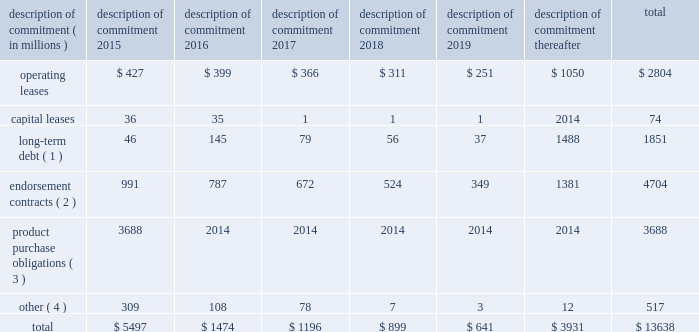Part ii on november 1 , 2011 , we entered into a committed credit facility agreement with a syndicate of banks which provides for up to $ 1 billion of borrowings with the option to increase borrowings to $ 1.5 billion with lender approval .
Following an extension agreement on september 17 , 2013 between the company and the syndicate of banks , the facility matures november 1 , 2017 , with a one-year extension option exercisable through october 31 , 2014 .
No amounts were outstanding under this facility as of may 31 , 2014 or 2013 .
We currently have long-term debt ratings of aa- and a1 from standard and poor 2019s corporation and moody 2019s investor services , respectively .
If our long- term debt rating were to decline , the facility fee and interest rate under our committed credit facility would increase .
Conversely , if our long-term debt rating were to improve , the facility fee and interest rate would decrease .
Changes in our long-term debt rating would not trigger acceleration of maturity of any then-outstanding borrowings or any future borrowings under the committed credit facility .
Under this committed revolving credit facility , we have agreed to various covenants .
These covenants include limits on our disposal of fixed assets , the amount of debt secured by liens we may incur , as well as a minimum capitalization ratio .
In the event we were to have any borrowings outstanding under this facility and failed to meet any covenant , and were unable to obtain a waiver from a majority of the banks in the syndicate , any borrowings would become immediately due and payable .
As of may 31 , 2014 , we were in full compliance with each of these covenants and believe it is unlikely we will fail to meet any of these covenants in the foreseeable future .
Liquidity is also provided by our $ 1 billion commercial paper program .
During the year ended may 31 , 2014 , we did not issue commercial paper , and as of may 31 , 2014 , there were no outstanding borrowings under this program .
We may continue to issue commercial paper or other debt securities during fiscal 2015 depending on general corporate needs .
We currently have short-term debt ratings of a1+ and p1 from standard and poor 2019s corporation and moody 2019s investor services , respectively .
As of may 31 , 2014 , we had cash , cash equivalents , and short-term investments totaling $ 5.1 billion , of which $ 2.5 billion was held by our foreign subsidiaries .
Cash equivalents and short-term investments consist primarily of deposits held at major banks , money market funds , commercial paper , corporate notes , u.s .
Treasury obligations , u.s .
Government sponsored enterprise obligations , and other investment grade fixed income securities .
Our fixed income investments are exposed to both credit and interest rate risk .
All of our investments are investment grade to minimize our credit risk .
While individual securities have varying durations , as of may 31 , 2014 the average duration of our short-term investments and cash equivalents portfolio was 126 days .
To date we have not experienced difficulty accessing the credit markets or incurred higher interest costs .
Future volatility in the capital markets , however , may increase costs associated with issuing commercial paper or other debt instruments or affect our ability to access those markets .
We believe that existing cash , cash equivalents , short-term investments , and cash generated by operations , together with access to external sources of funds as described above , will be sufficient to meet our domestic and foreign capital needs in the foreseeable future .
We utilize a variety of tax planning and financing strategies to manage our worldwide cash and deploy funds to locations where they are needed .
We routinely repatriate a portion of our foreign earnings for which u.s .
Taxes have previously been provided .
We also indefinitely reinvest a significant portion of our foreign earnings , and our current plans do not demonstrate a need to repatriate these earnings .
Should we require additional capital in the united states , we may elect to repatriate indefinitely reinvested foreign funds or raise capital in the united states through debt .
If we were to repatriate indefinitely reinvested foreign funds , we would be required to accrue and pay additional u.s .
Taxes less applicable foreign tax credits .
If we elect to raise capital in the united states through debt , we would incur additional interest expense .
Off-balance sheet arrangements in connection with various contracts and agreements , we routinely provide indemnification relating to the enforceability of intellectual property rights , coverage for legal issues that arise and other items where we are acting as the guarantor .
Currently , we have several such agreements in place .
However , based on our historical experience and the estimated probability of future loss , we have determined that the fair value of such indemnification is not material to our financial position or results of operations .
Contractual obligations our significant long-term contractual obligations as of may 31 , 2014 and significant endorsement contracts entered into through the date of this report are as follows: .
( 1 ) the cash payments due for long-term debt include estimated interest payments .
Estimates of interest payments are based on outstanding principal amounts , applicable fixed interest rates or currently effective interest rates as of may 31 , 2014 ( if variable ) , timing of scheduled payments , and the term of the debt obligations .
( 2 ) the amounts listed for endorsement contracts represent approximate amounts of base compensation and minimum guaranteed royalty fees we are obligated to pay athlete and sport team endorsers of our products .
Actual payments under some contracts may be higher than the amounts listed as these contracts provide for bonuses to be paid to the endorsers based upon athletic achievements and/or royalties on product sales in future periods .
Actual payments under some contracts may also be lower as these contracts include provisions for reduced payments if athletic performance declines in future periods .
In addition to the cash payments , we are obligated to furnish our endorsers with nike product for their use .
It is not possible to determine how much we will spend on this product on an annual basis as the contracts generally do not stipulate a specific amount of cash to be spent on the product .
The amount of product provided to the endorsers will depend on many factors , including general playing conditions , the number of sporting events in which they participate , and our own decisions regarding product and marketing initiatives .
In addition , the costs to design , develop , source , and purchase the products furnished to the endorsers are incurred over a period of time and are not necessarily tracked separately from similar costs incurred for products sold to customers .
( 3 ) we generally order product at least four to five months in advance of sale based primarily on futures orders received from customers .
The amounts listed for product purchase obligations represent agreements ( including open purchase orders ) to purchase products in the ordinary course of business that are enforceable and legally binding and that specify all significant terms .
In some cases , prices are subject to change throughout the production process .
The reported amounts exclude product purchase liabilities included in accounts payable on the consolidated balance sheet as of may 31 , 2014 .
( 4 ) other amounts primarily include service and marketing commitments made in the ordinary course of business .
The amounts represent the minimum payments required by legally binding contracts and agreements that specify all significant terms , including open purchase orders for non-product purchases .
The reported amounts exclude those liabilities included in accounts payable or accrued liabilities on the consolidated balance sheet as of may 31 , 2014 .
Nike , inc .
2014 annual report and notice of annual meeting 79 .
What percentage of the total for 2015 were due to to operating leases? 
Computations: (427 / 5497)
Answer: 0.07768. Part ii on november 1 , 2011 , we entered into a committed credit facility agreement with a syndicate of banks which provides for up to $ 1 billion of borrowings with the option to increase borrowings to $ 1.5 billion with lender approval .
Following an extension agreement on september 17 , 2013 between the company and the syndicate of banks , the facility matures november 1 , 2017 , with a one-year extension option exercisable through october 31 , 2014 .
No amounts were outstanding under this facility as of may 31 , 2014 or 2013 .
We currently have long-term debt ratings of aa- and a1 from standard and poor 2019s corporation and moody 2019s investor services , respectively .
If our long- term debt rating were to decline , the facility fee and interest rate under our committed credit facility would increase .
Conversely , if our long-term debt rating were to improve , the facility fee and interest rate would decrease .
Changes in our long-term debt rating would not trigger acceleration of maturity of any then-outstanding borrowings or any future borrowings under the committed credit facility .
Under this committed revolving credit facility , we have agreed to various covenants .
These covenants include limits on our disposal of fixed assets , the amount of debt secured by liens we may incur , as well as a minimum capitalization ratio .
In the event we were to have any borrowings outstanding under this facility and failed to meet any covenant , and were unable to obtain a waiver from a majority of the banks in the syndicate , any borrowings would become immediately due and payable .
As of may 31 , 2014 , we were in full compliance with each of these covenants and believe it is unlikely we will fail to meet any of these covenants in the foreseeable future .
Liquidity is also provided by our $ 1 billion commercial paper program .
During the year ended may 31 , 2014 , we did not issue commercial paper , and as of may 31 , 2014 , there were no outstanding borrowings under this program .
We may continue to issue commercial paper or other debt securities during fiscal 2015 depending on general corporate needs .
We currently have short-term debt ratings of a1+ and p1 from standard and poor 2019s corporation and moody 2019s investor services , respectively .
As of may 31 , 2014 , we had cash , cash equivalents , and short-term investments totaling $ 5.1 billion , of which $ 2.5 billion was held by our foreign subsidiaries .
Cash equivalents and short-term investments consist primarily of deposits held at major banks , money market funds , commercial paper , corporate notes , u.s .
Treasury obligations , u.s .
Government sponsored enterprise obligations , and other investment grade fixed income securities .
Our fixed income investments are exposed to both credit and interest rate risk .
All of our investments are investment grade to minimize our credit risk .
While individual securities have varying durations , as of may 31 , 2014 the average duration of our short-term investments and cash equivalents portfolio was 126 days .
To date we have not experienced difficulty accessing the credit markets or incurred higher interest costs .
Future volatility in the capital markets , however , may increase costs associated with issuing commercial paper or other debt instruments or affect our ability to access those markets .
We believe that existing cash , cash equivalents , short-term investments , and cash generated by operations , together with access to external sources of funds as described above , will be sufficient to meet our domestic and foreign capital needs in the foreseeable future .
We utilize a variety of tax planning and financing strategies to manage our worldwide cash and deploy funds to locations where they are needed .
We routinely repatriate a portion of our foreign earnings for which u.s .
Taxes have previously been provided .
We also indefinitely reinvest a significant portion of our foreign earnings , and our current plans do not demonstrate a need to repatriate these earnings .
Should we require additional capital in the united states , we may elect to repatriate indefinitely reinvested foreign funds or raise capital in the united states through debt .
If we were to repatriate indefinitely reinvested foreign funds , we would be required to accrue and pay additional u.s .
Taxes less applicable foreign tax credits .
If we elect to raise capital in the united states through debt , we would incur additional interest expense .
Off-balance sheet arrangements in connection with various contracts and agreements , we routinely provide indemnification relating to the enforceability of intellectual property rights , coverage for legal issues that arise and other items where we are acting as the guarantor .
Currently , we have several such agreements in place .
However , based on our historical experience and the estimated probability of future loss , we have determined that the fair value of such indemnification is not material to our financial position or results of operations .
Contractual obligations our significant long-term contractual obligations as of may 31 , 2014 and significant endorsement contracts entered into through the date of this report are as follows: .
( 1 ) the cash payments due for long-term debt include estimated interest payments .
Estimates of interest payments are based on outstanding principal amounts , applicable fixed interest rates or currently effective interest rates as of may 31 , 2014 ( if variable ) , timing of scheduled payments , and the term of the debt obligations .
( 2 ) the amounts listed for endorsement contracts represent approximate amounts of base compensation and minimum guaranteed royalty fees we are obligated to pay athlete and sport team endorsers of our products .
Actual payments under some contracts may be higher than the amounts listed as these contracts provide for bonuses to be paid to the endorsers based upon athletic achievements and/or royalties on product sales in future periods .
Actual payments under some contracts may also be lower as these contracts include provisions for reduced payments if athletic performance declines in future periods .
In addition to the cash payments , we are obligated to furnish our endorsers with nike product for their use .
It is not possible to determine how much we will spend on this product on an annual basis as the contracts generally do not stipulate a specific amount of cash to be spent on the product .
The amount of product provided to the endorsers will depend on many factors , including general playing conditions , the number of sporting events in which they participate , and our own decisions regarding product and marketing initiatives .
In addition , the costs to design , develop , source , and purchase the products furnished to the endorsers are incurred over a period of time and are not necessarily tracked separately from similar costs incurred for products sold to customers .
( 3 ) we generally order product at least four to five months in advance of sale based primarily on futures orders received from customers .
The amounts listed for product purchase obligations represent agreements ( including open purchase orders ) to purchase products in the ordinary course of business that are enforceable and legally binding and that specify all significant terms .
In some cases , prices are subject to change throughout the production process .
The reported amounts exclude product purchase liabilities included in accounts payable on the consolidated balance sheet as of may 31 , 2014 .
( 4 ) other amounts primarily include service and marketing commitments made in the ordinary course of business .
The amounts represent the minimum payments required by legally binding contracts and agreements that specify all significant terms , including open purchase orders for non-product purchases .
The reported amounts exclude those liabilities included in accounts payable or accrued liabilities on the consolidated balance sheet as of may 31 , 2014 .
Nike , inc .
2014 annual report and notice of annual meeting 79 .
What percent of the total for all years was made up from contributions in 2017? 
Computations: (1196 / 13638)
Answer: 0.0877. 